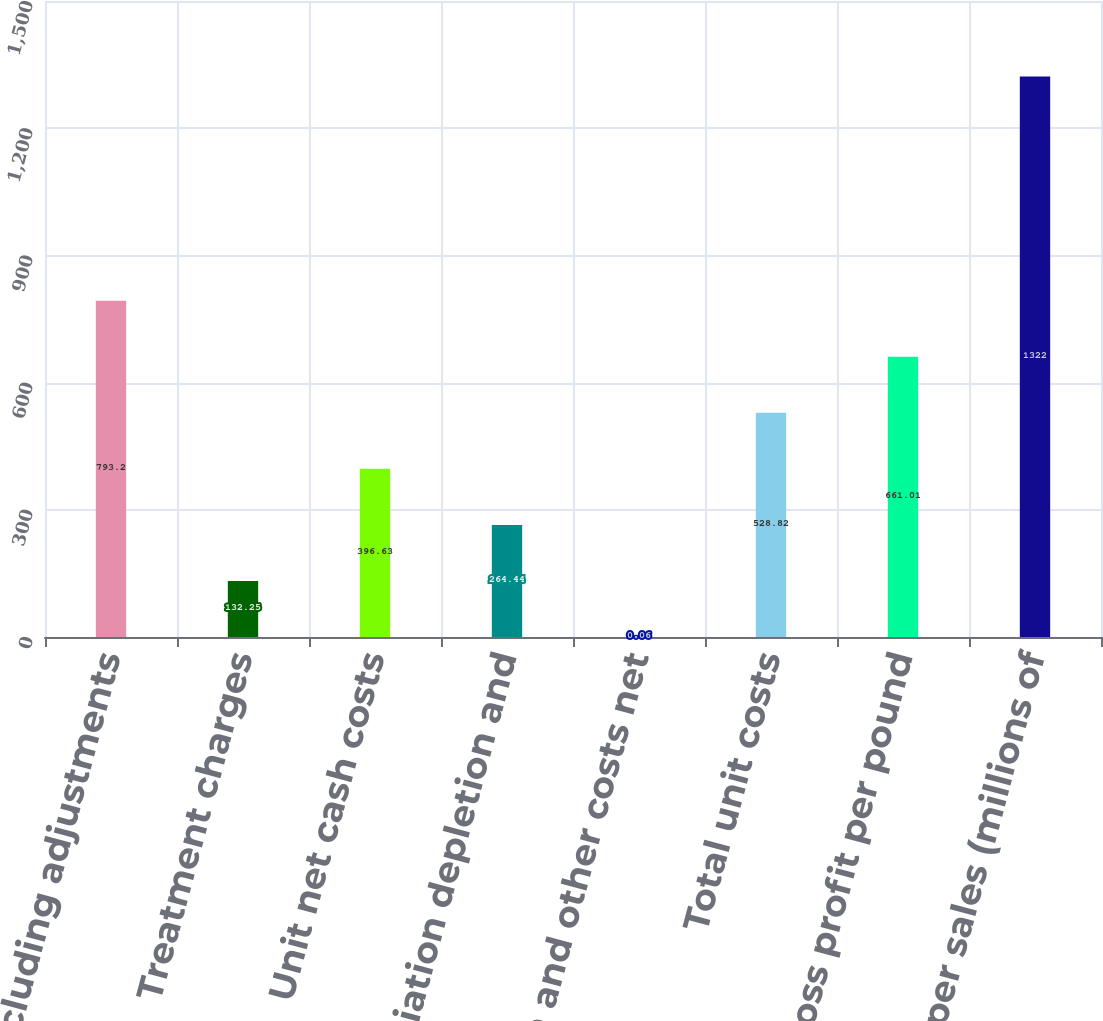Convert chart to OTSL. <chart><loc_0><loc_0><loc_500><loc_500><bar_chart><fcel>Revenues excluding adjustments<fcel>Treatment charges<fcel>Unit net cash costs<fcel>Depreciation depletion and<fcel>Noncash and other costs net<fcel>Total unit costs<fcel>Gross profit per pound<fcel>Copper sales (millions of<nl><fcel>793.2<fcel>132.25<fcel>396.63<fcel>264.44<fcel>0.06<fcel>528.82<fcel>661.01<fcel>1322<nl></chart> 